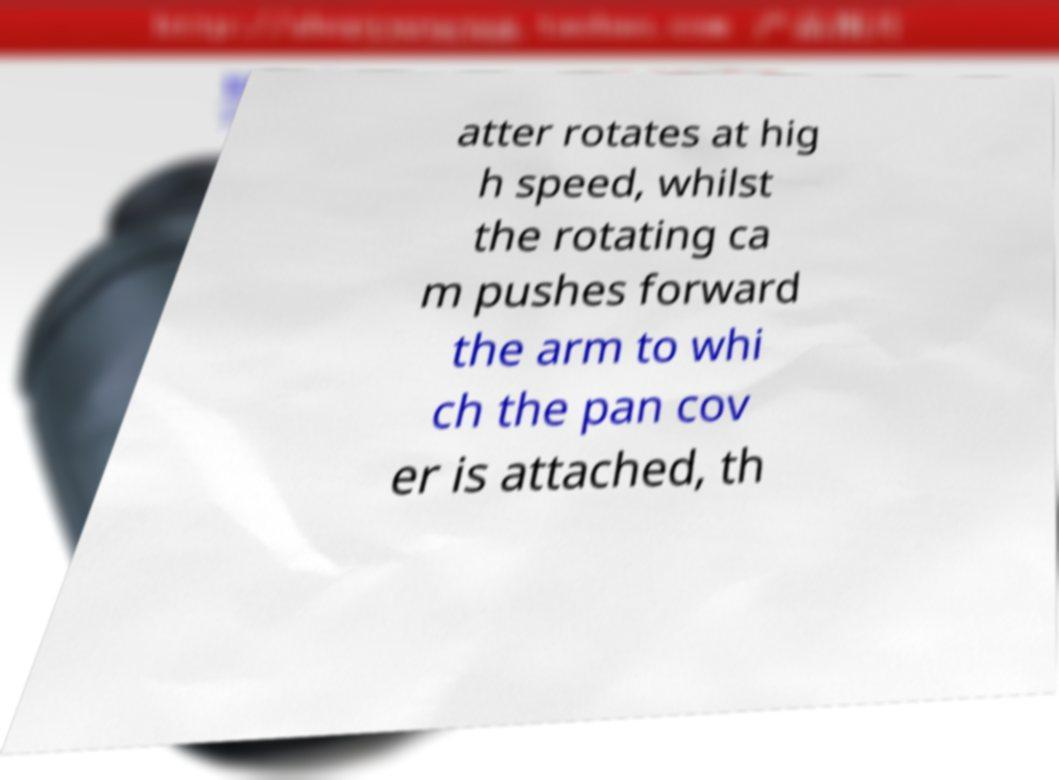Please identify and transcribe the text found in this image. atter rotates at hig h speed, whilst the rotating ca m pushes forward the arm to whi ch the pan cov er is attached, th 